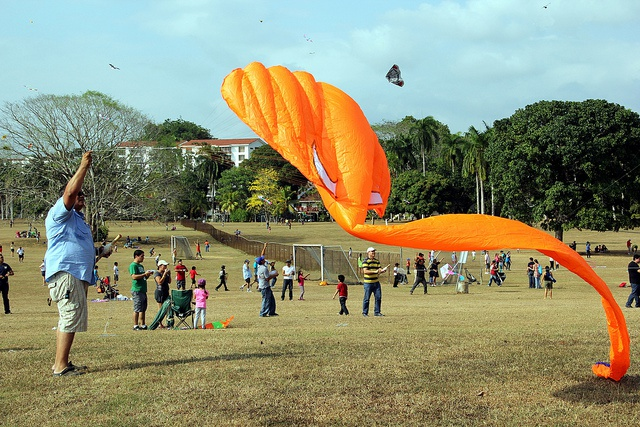Describe the objects in this image and their specific colors. I can see people in lightblue, olive, and black tones, kite in lightblue, orange, red, and gold tones, people in lightblue, gray, and black tones, people in lightblue, black, gray, tan, and maroon tones, and people in lightblue, black, olive, gray, and navy tones in this image. 